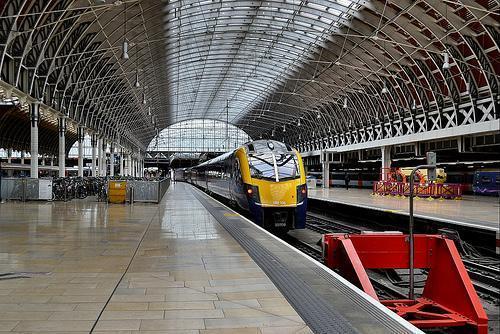How many trains?
Give a very brief answer. 1. 